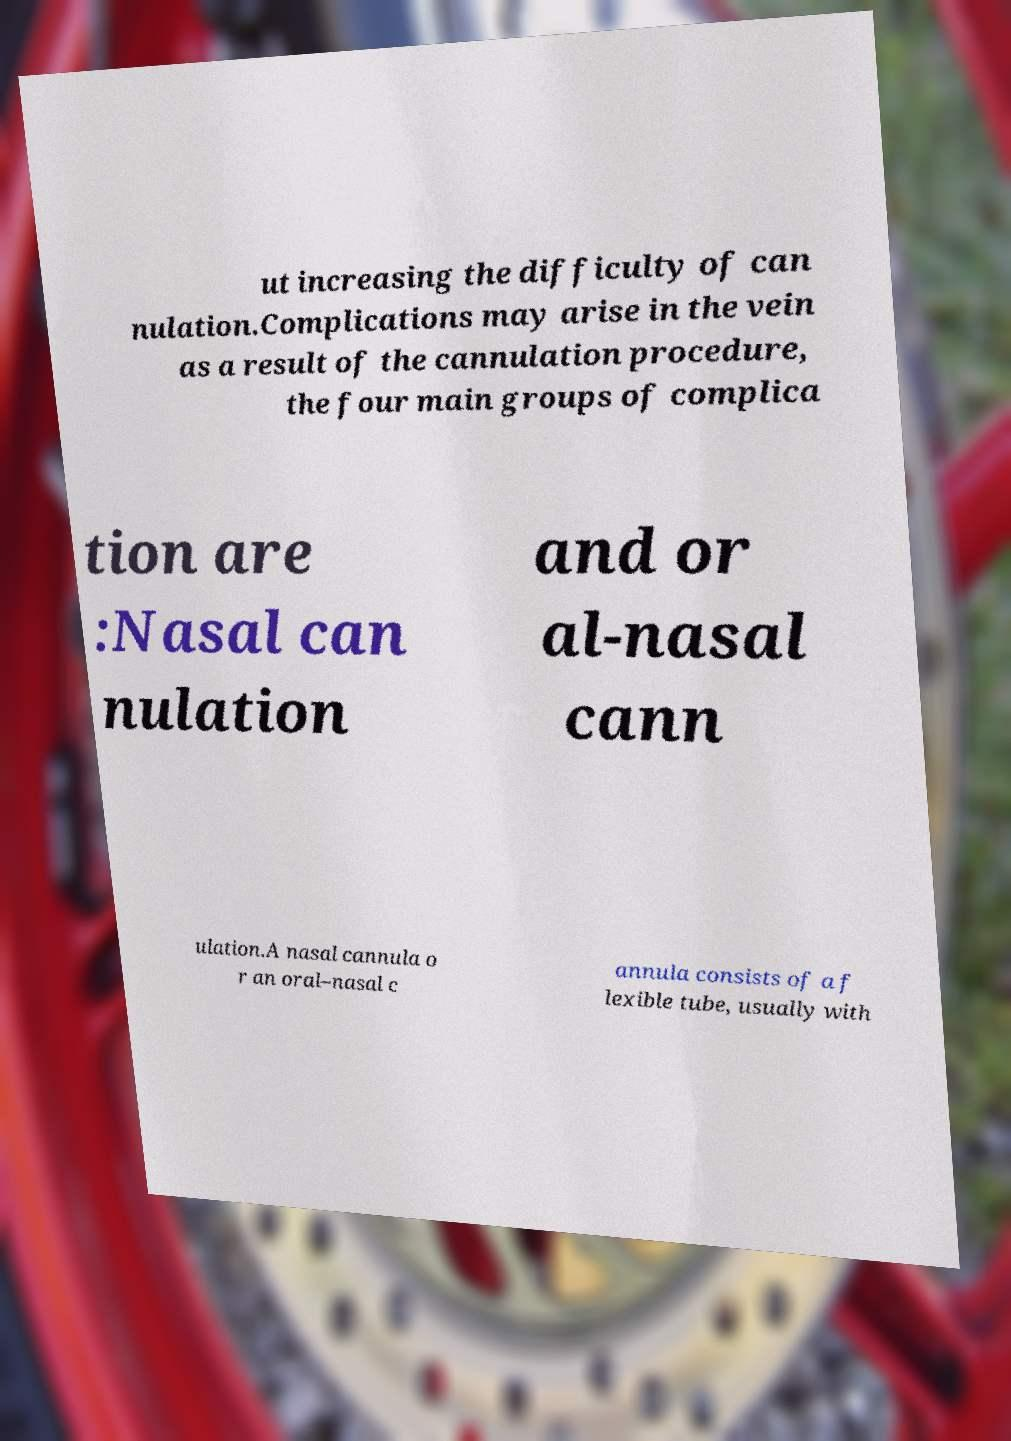I need the written content from this picture converted into text. Can you do that? ut increasing the difficulty of can nulation.Complications may arise in the vein as a result of the cannulation procedure, the four main groups of complica tion are :Nasal can nulation and or al-nasal cann ulation.A nasal cannula o r an oral–nasal c annula consists of a f lexible tube, usually with 